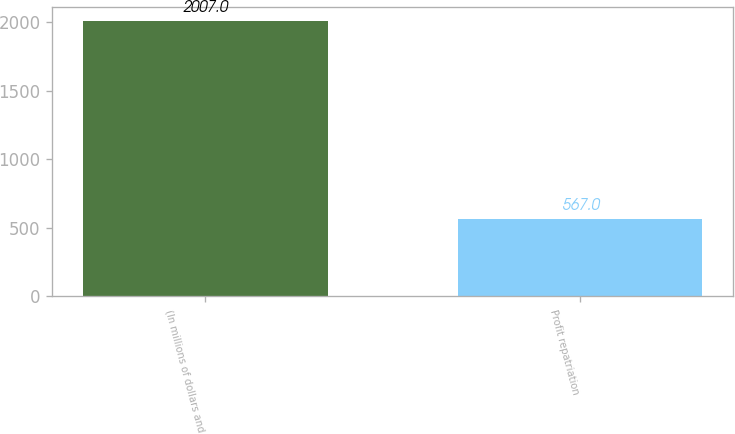Convert chart. <chart><loc_0><loc_0><loc_500><loc_500><bar_chart><fcel>(In millions of dollars and<fcel>Profit repatriation<nl><fcel>2007<fcel>567<nl></chart> 